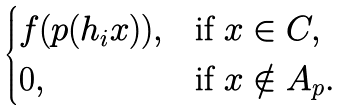<formula> <loc_0><loc_0><loc_500><loc_500>\begin{cases} f ( p ( h _ { i } x ) ) , & \text {if } x \in C , \\ 0 , & \text {if } x \notin A _ { p } . \end{cases}</formula> 